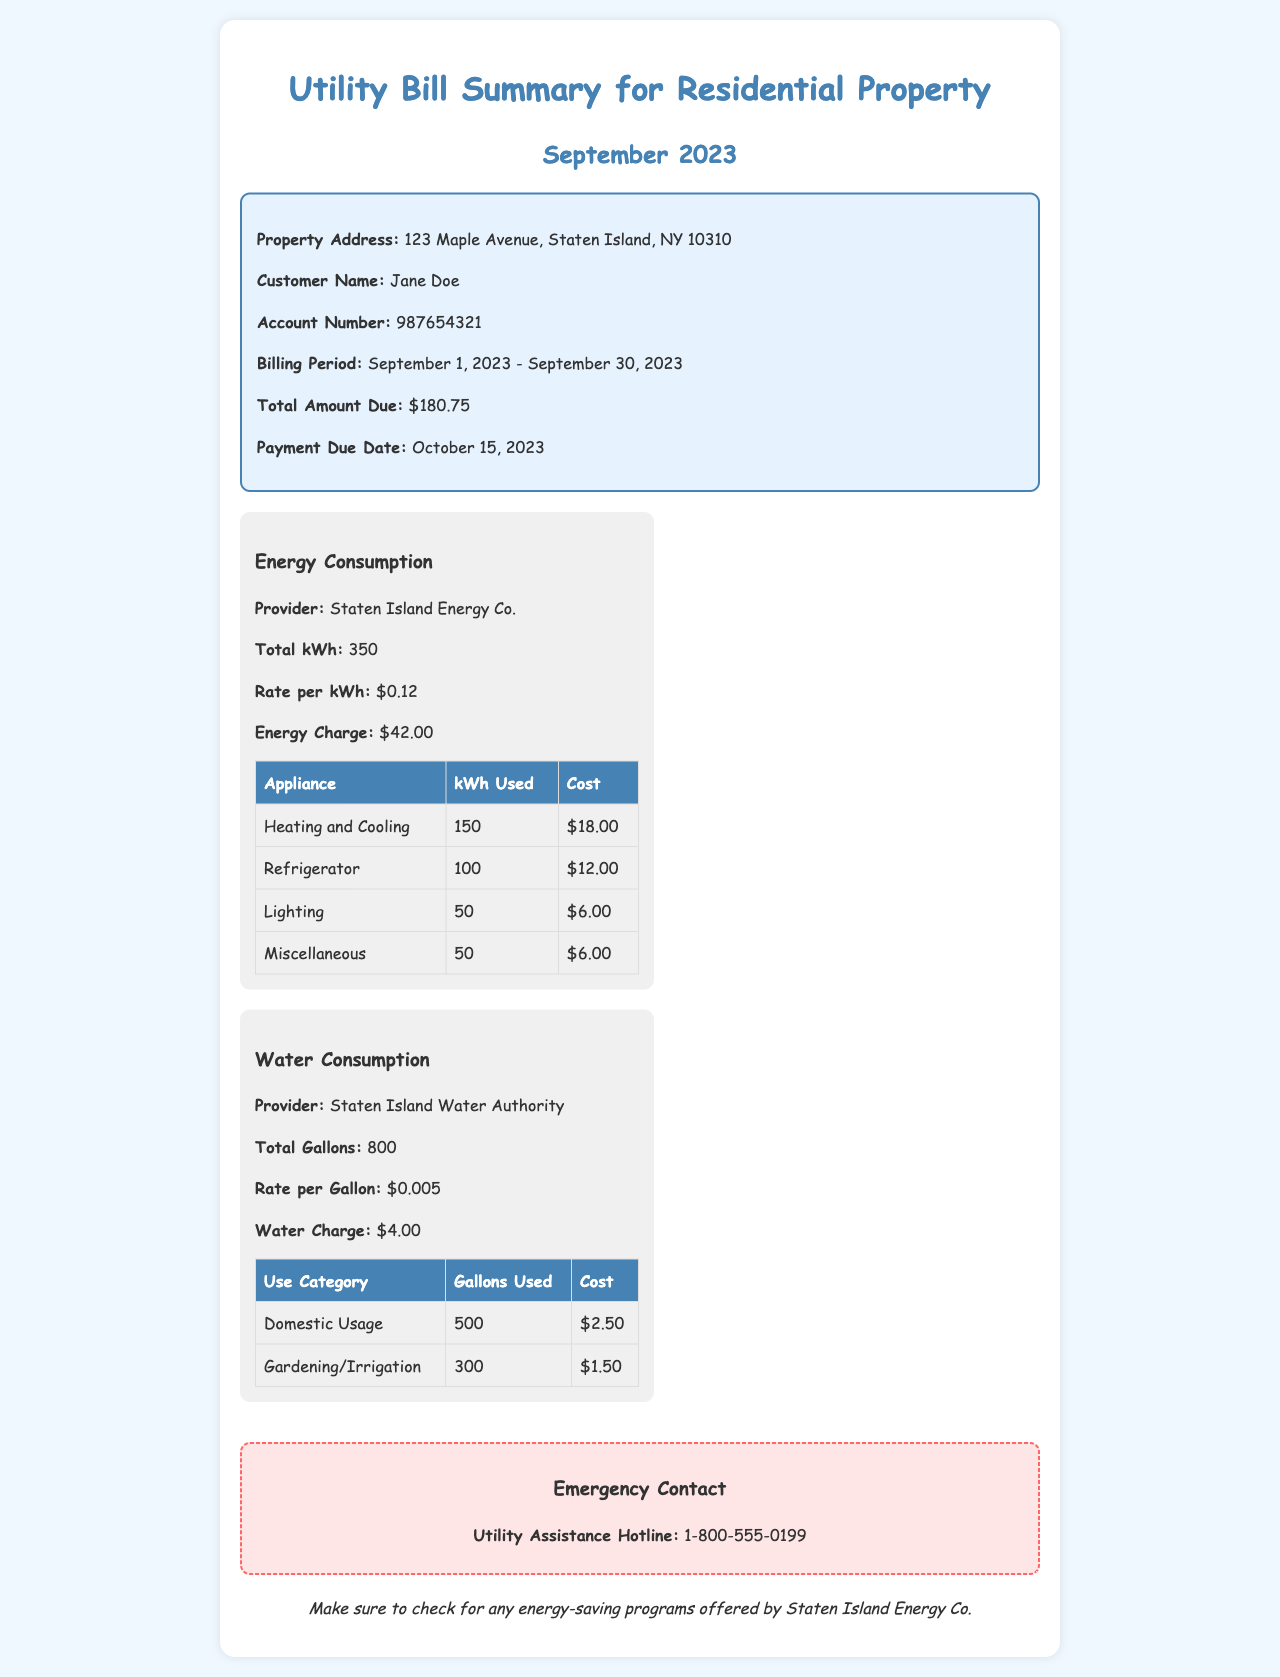What is the property address? The property address is specifically mentioned in the summary box of the document.
Answer: 123 Maple Avenue, Staten Island, NY 10310 What is the total amount due? The total amount due is summarized in the document as the amount to be paid for the billing period.
Answer: $180.75 How many gallons of water were consumed? The document provides specific information about total water consumption.
Answer: 800 What is the rate per kWh for energy consumption? The rate per kWh is mentioned under energy consumption details in the document.
Answer: $0.12 What was the cost for the Refrigerator's energy usage? The provided table under energy consumption lists costs for various appliances, including the Refrigerator.
Answer: $12.00 How many gallons were used for domestic usage? The document lists the gallons used for different categories, including domestic usage.
Answer: 500 What is the water charge? The water charge is specified in the summary of water consumption details.
Answer: $4.00 Who is the energy provider? The document explicitly mentions the energy provider in the energy consumption section.
Answer: Staten Island Energy Co What is the payment due date? The payment due date is directly stated in the summary box of the document.
Answer: October 15, 2023 